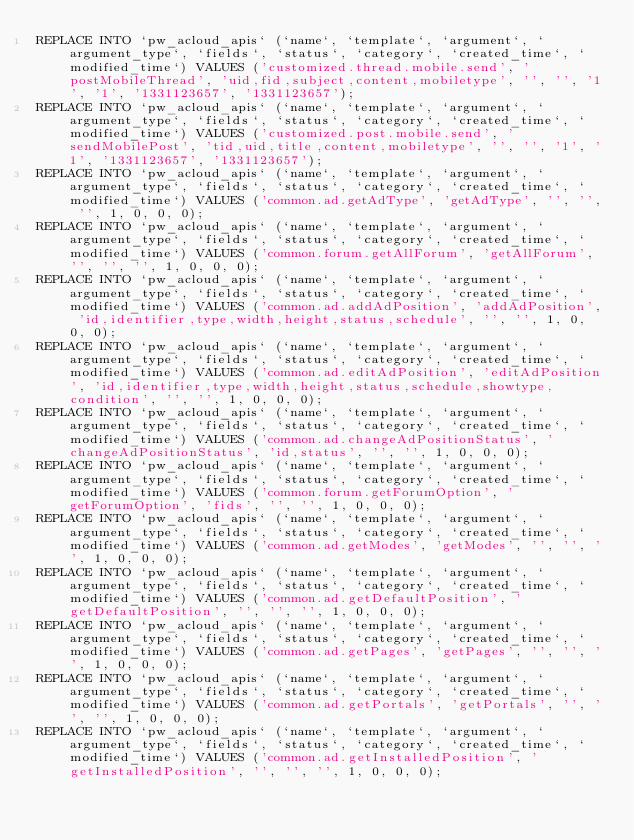<code> <loc_0><loc_0><loc_500><loc_500><_SQL_>REPLACE INTO `pw_acloud_apis` (`name`, `template`, `argument`, `argument_type`, `fields`, `status`, `category`, `created_time`, `modified_time`) VALUES ('customized.thread.mobile.send', 'postMobileThread', 'uid,fid,subject,content,mobiletype', '', '', '1', '1', '1331123657', '1331123657');
REPLACE INTO `pw_acloud_apis` (`name`, `template`, `argument`, `argument_type`, `fields`, `status`, `category`, `created_time`, `modified_time`) VALUES ('customized.post.mobile.send', 'sendMobilePost', 'tid,uid,title,content,mobiletype', '', '', '1', '1', '1331123657', '1331123657');
REPLACE INTO `pw_acloud_apis` (`name`, `template`, `argument`, `argument_type`, `fields`, `status`, `category`, `created_time`, `modified_time`) VALUES ('common.ad.getAdType', 'getAdType', '', '', '', 1, 0, 0, 0);
REPLACE INTO `pw_acloud_apis` (`name`, `template`, `argument`, `argument_type`, `fields`, `status`, `category`, `created_time`, `modified_time`) VALUES ('common.forum.getAllForum', 'getAllForum', '', '', '', 1, 0, 0, 0);
REPLACE INTO `pw_acloud_apis` (`name`, `template`, `argument`, `argument_type`, `fields`, `status`, `category`, `created_time`, `modified_time`) VALUES ('common.ad.addAdPosition', 'addAdPosition', 'id,identifier,type,width,height,status,schedule', '', '', 1, 0, 0, 0);
REPLACE INTO `pw_acloud_apis` (`name`, `template`, `argument`, `argument_type`, `fields`, `status`, `category`, `created_time`, `modified_time`) VALUES ('common.ad.editAdPosition', 'editAdPosition', 'id,identifier,type,width,height,status,schedule,showtype,condition', '', '', 1, 0, 0, 0);
REPLACE INTO `pw_acloud_apis` (`name`, `template`, `argument`, `argument_type`, `fields`, `status`, `category`, `created_time`, `modified_time`) VALUES ('common.ad.changeAdPositionStatus', 'changeAdPositionStatus', 'id,status', '', '', 1, 0, 0, 0);
REPLACE INTO `pw_acloud_apis` (`name`, `template`, `argument`, `argument_type`, `fields`, `status`, `category`, `created_time`, `modified_time`) VALUES ('common.forum.getForumOption', 'getForumOption', 'fids', '', '', 1, 0, 0, 0);
REPLACE INTO `pw_acloud_apis` (`name`, `template`, `argument`, `argument_type`, `fields`, `status`, `category`, `created_time`, `modified_time`) VALUES ('common.ad.getModes', 'getModes', '', '', '', 1, 0, 0, 0);
REPLACE INTO `pw_acloud_apis` (`name`, `template`, `argument`, `argument_type`, `fields`, `status`, `category`, `created_time`, `modified_time`) VALUES ('common.ad.getDefaultPosition', 'getDefaultPosition', '', '', '', 1, 0, 0, 0);
REPLACE INTO `pw_acloud_apis` (`name`, `template`, `argument`, `argument_type`, `fields`, `status`, `category`, `created_time`, `modified_time`) VALUES ('common.ad.getPages', 'getPages', '', '', '', 1, 0, 0, 0);
REPLACE INTO `pw_acloud_apis` (`name`, `template`, `argument`, `argument_type`, `fields`, `status`, `category`, `created_time`, `modified_time`) VALUES ('common.ad.getPortals', 'getPortals', '', '', '', 1, 0, 0, 0);
REPLACE INTO `pw_acloud_apis` (`name`, `template`, `argument`, `argument_type`, `fields`, `status`, `category`, `created_time`, `modified_time`) VALUES ('common.ad.getInstalledPosition', 'getInstalledPosition', '', '', '', 1, 0, 0, 0);</code> 